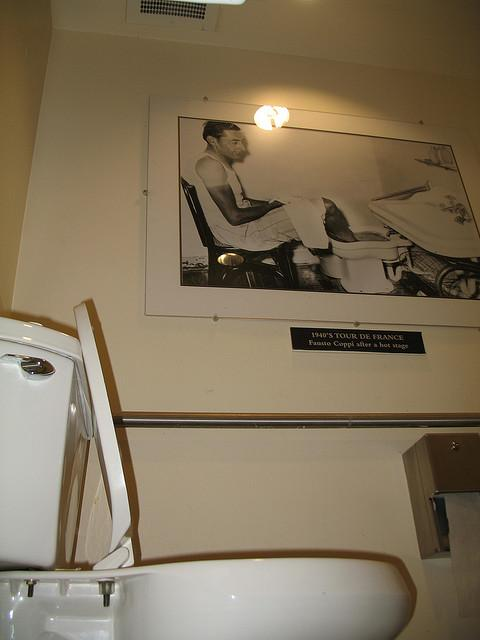What kind of athlete was the man in the black and white image most likely? Please explain your reasoning. cyclist. He looks to be a football player 